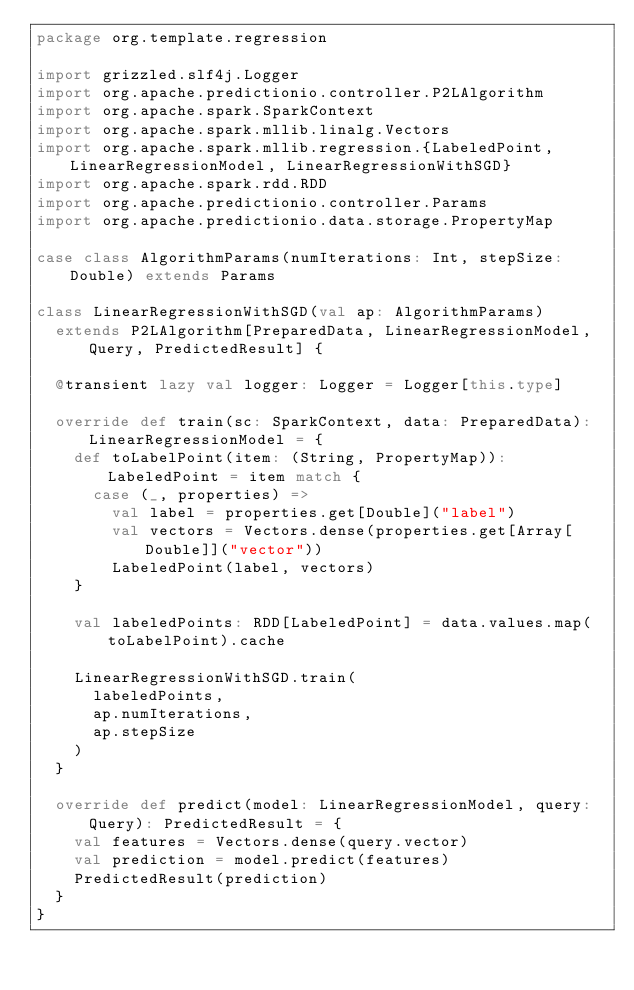Convert code to text. <code><loc_0><loc_0><loc_500><loc_500><_Scala_>package org.template.regression

import grizzled.slf4j.Logger
import org.apache.predictionio.controller.P2LAlgorithm
import org.apache.spark.SparkContext
import org.apache.spark.mllib.linalg.Vectors
import org.apache.spark.mllib.regression.{LabeledPoint, LinearRegressionModel, LinearRegressionWithSGD}
import org.apache.spark.rdd.RDD
import org.apache.predictionio.controller.Params
import org.apache.predictionio.data.storage.PropertyMap

case class AlgorithmParams(numIterations: Int, stepSize: Double) extends Params

class LinearRegressionWithSGD(val ap: AlgorithmParams)
  extends P2LAlgorithm[PreparedData, LinearRegressionModel, Query, PredictedResult] {

  @transient lazy val logger: Logger = Logger[this.type]

  override def train(sc: SparkContext, data: PreparedData): LinearRegressionModel = {
    def toLabelPoint(item: (String, PropertyMap)): LabeledPoint = item match {
      case (_, properties) =>
        val label = properties.get[Double]("label")
        val vectors = Vectors.dense(properties.get[Array[Double]]("vector"))
        LabeledPoint(label, vectors)
    }

    val labeledPoints: RDD[LabeledPoint] = data.values.map(toLabelPoint).cache

    LinearRegressionWithSGD.train(
      labeledPoints,
      ap.numIterations,
      ap.stepSize
    )
  }

  override def predict(model: LinearRegressionModel, query: Query): PredictedResult = {
    val features = Vectors.dense(query.vector)
    val prediction = model.predict(features)
    PredictedResult(prediction)
  }
}
</code> 